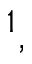<formula> <loc_0><loc_0><loc_500><loc_500>^ { 1 } ,</formula> 